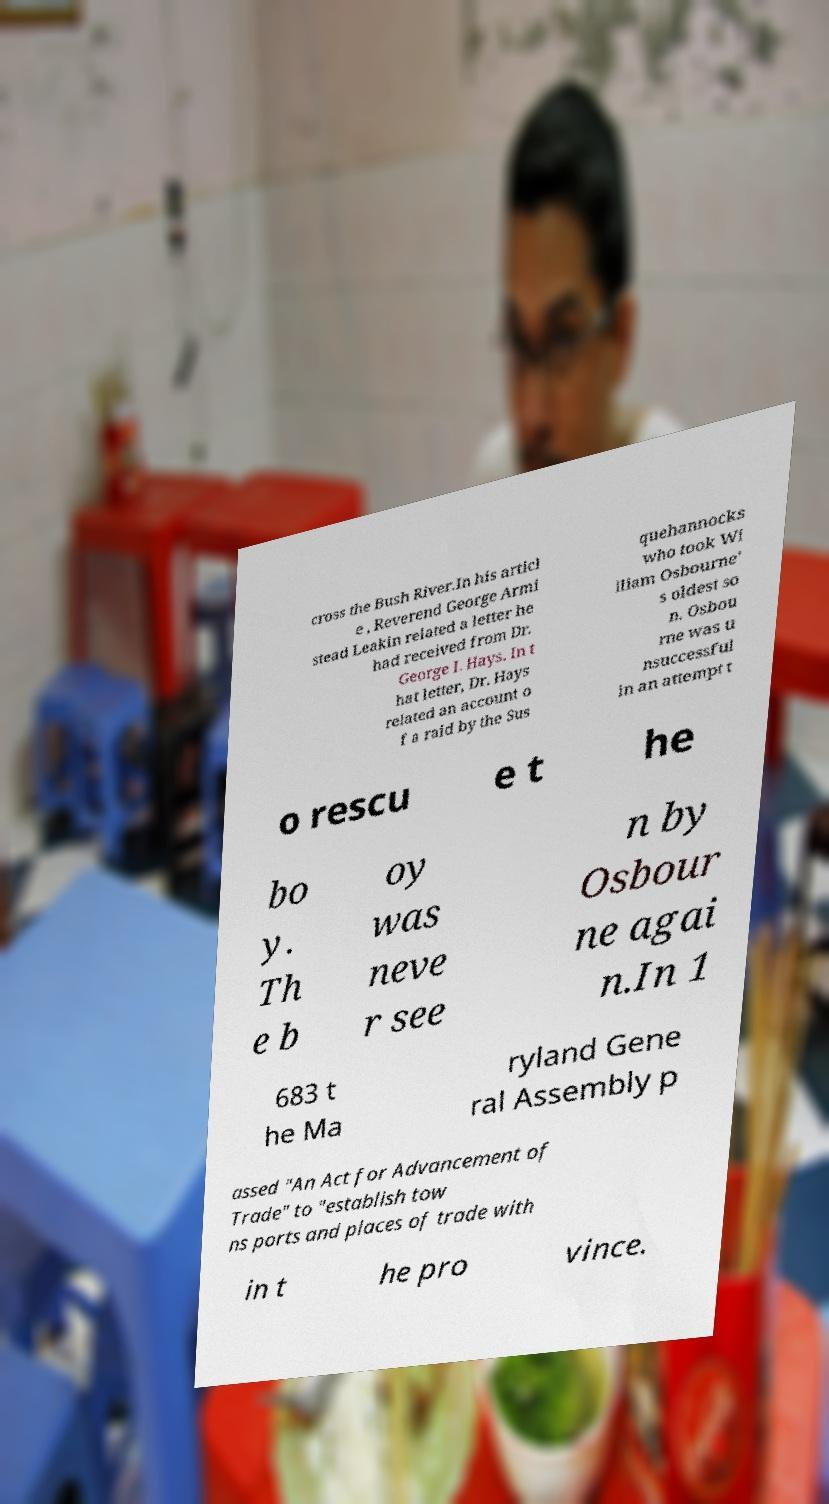What messages or text are displayed in this image? I need them in a readable, typed format. cross the Bush River.In his articl e , Reverend George Armi stead Leakin related a letter he had received from Dr. George I. Hays. In t hat letter, Dr. Hays related an account o f a raid by the Sus quehannocks who took Wi lliam Osbourne' s oldest so n. Osbou rne was u nsuccessful in an attempt t o rescu e t he bo y. Th e b oy was neve r see n by Osbour ne agai n.In 1 683 t he Ma ryland Gene ral Assembly p assed "An Act for Advancement of Trade" to "establish tow ns ports and places of trade with in t he pro vince. 